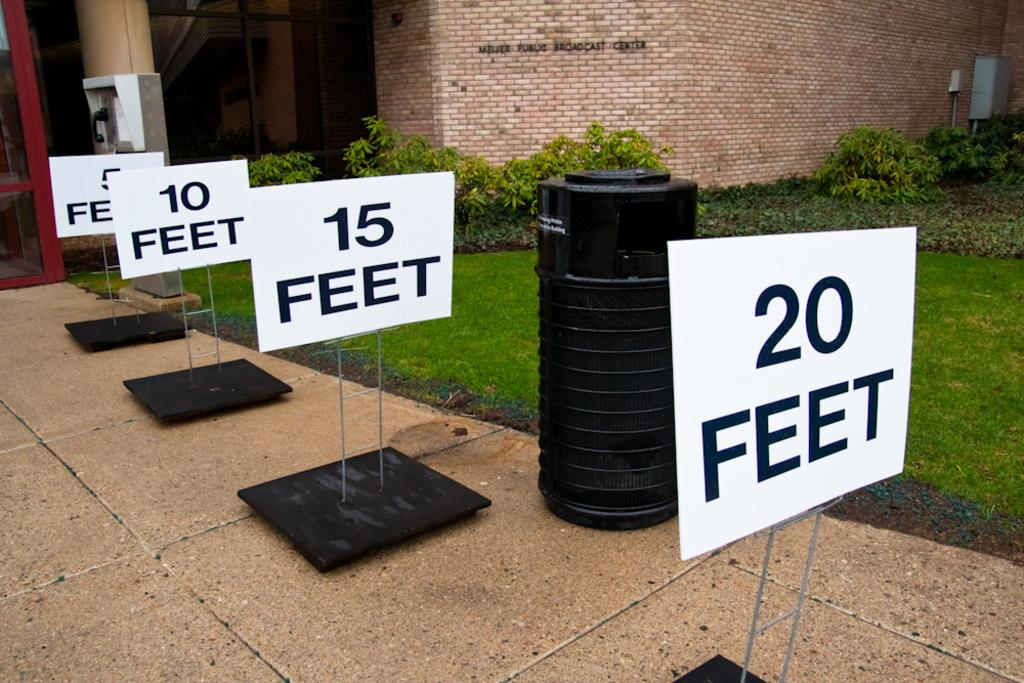<image>
Render a clear and concise summary of the photo. White signs show number of feet such as 20 feet, then 15 feet, etc. 